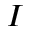Convert formula to latex. <formula><loc_0><loc_0><loc_500><loc_500>I</formula> 